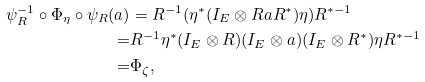<formula> <loc_0><loc_0><loc_500><loc_500>\psi _ { R } ^ { - 1 } \circ \Phi _ { \eta } \circ \psi _ { R } ( a ) & = R ^ { - 1 } ( \eta ^ { * } ( I _ { E } \otimes R a R ^ { * } ) \eta ) R ^ { * - 1 } \\ = & R ^ { - 1 } \eta ^ { * } ( I _ { E } \otimes R ) ( I _ { E } \otimes a ) ( I _ { E } \otimes R ^ { * } ) \eta R ^ { * - 1 } \\ = & \Phi _ { \zeta } ,</formula> 